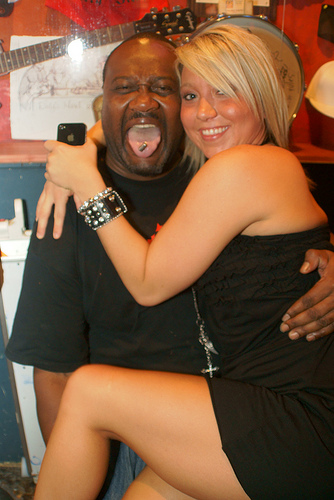<image>
Can you confirm if the guitar neck is on the bracelet? No. The guitar neck is not positioned on the bracelet. They may be near each other, but the guitar neck is not supported by or resting on top of the bracelet. Where is the drawing in relation to the guitar? Is it behind the guitar? Yes. From this viewpoint, the drawing is positioned behind the guitar, with the guitar partially or fully occluding the drawing. 